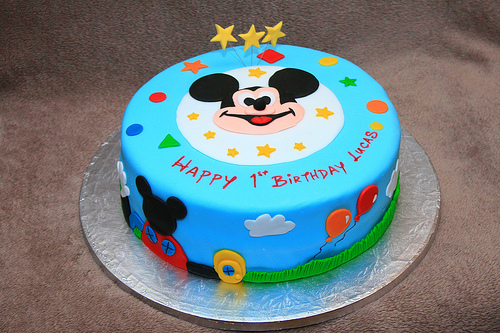<image>
Can you confirm if the mickey is on the birthday cake? Yes. Looking at the image, I can see the mickey is positioned on top of the birthday cake, with the birthday cake providing support. 